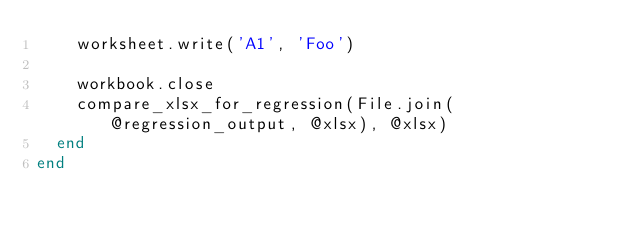<code> <loc_0><loc_0><loc_500><loc_500><_Ruby_>    worksheet.write('A1', 'Foo')

    workbook.close
    compare_xlsx_for_regression(File.join(@regression_output, @xlsx), @xlsx)
  end
end
</code> 